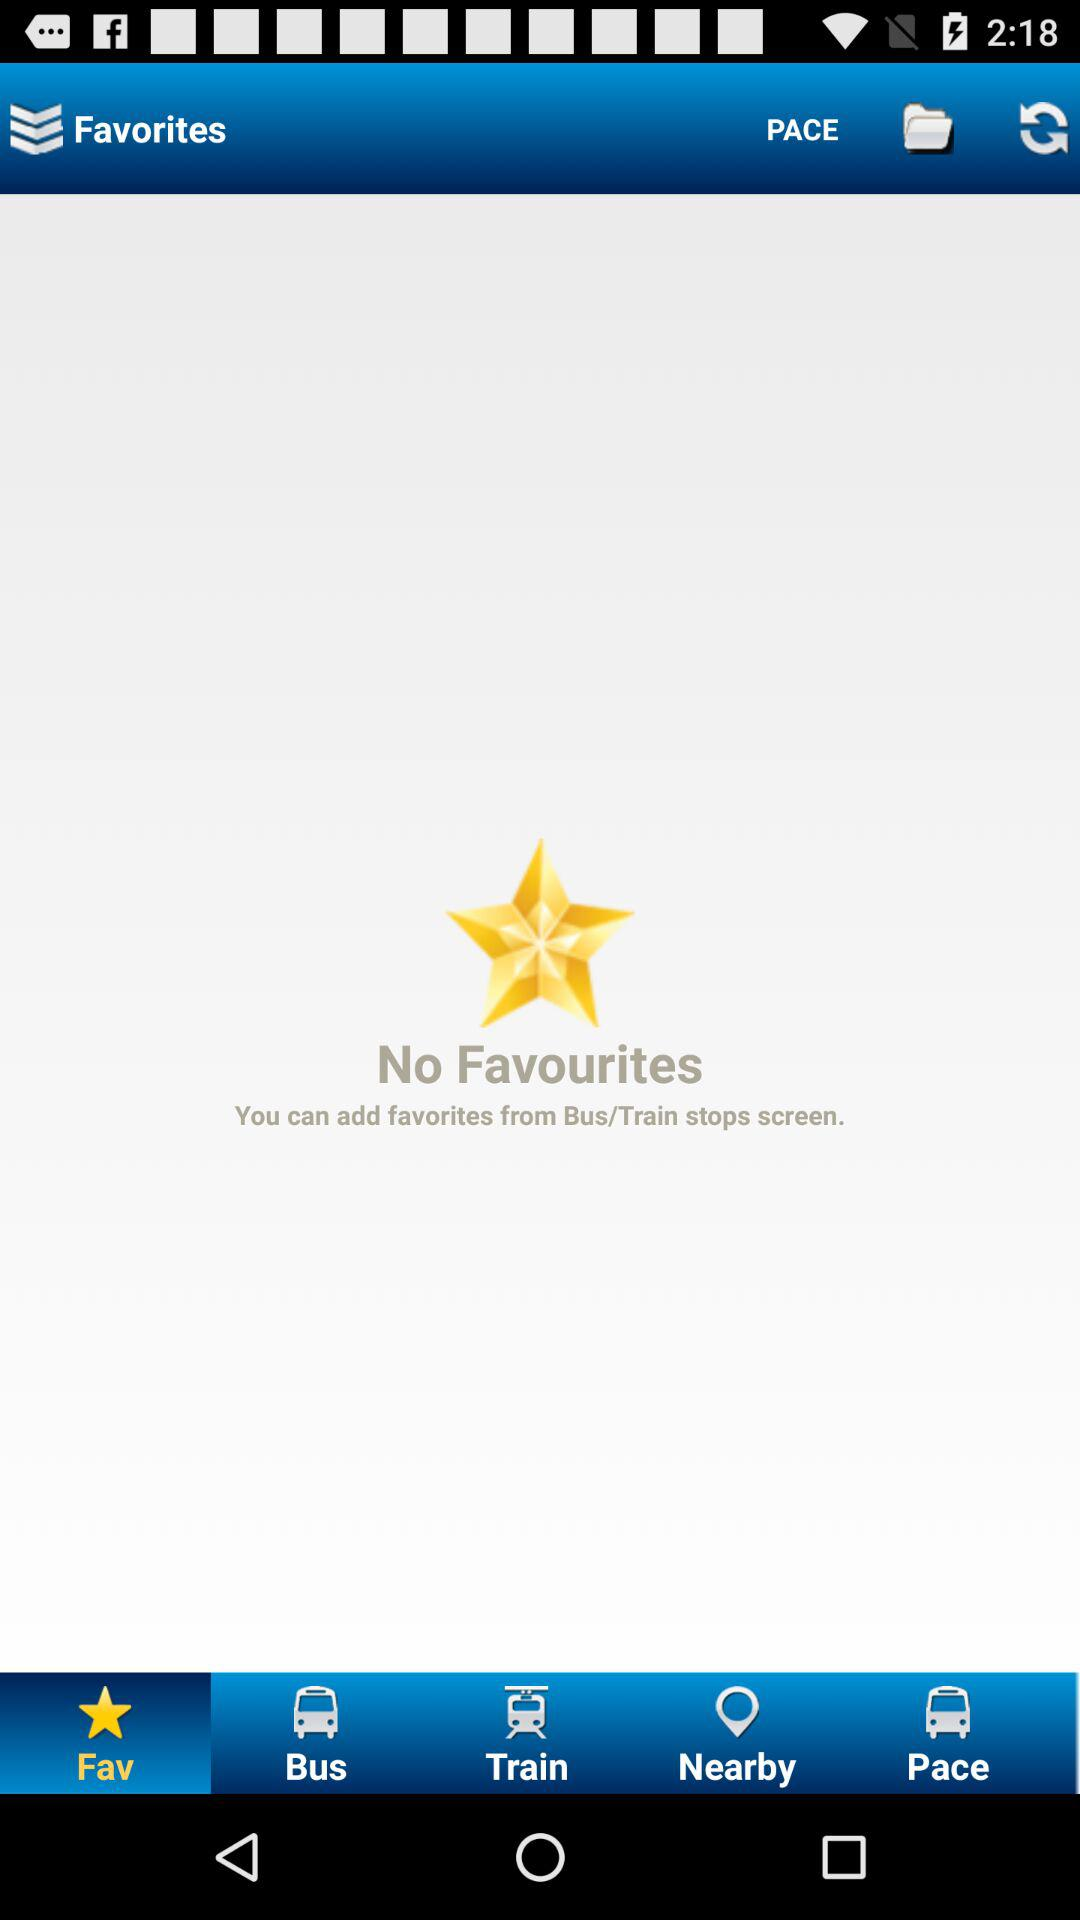How many favourites are there right now? There are no favourites right now. 